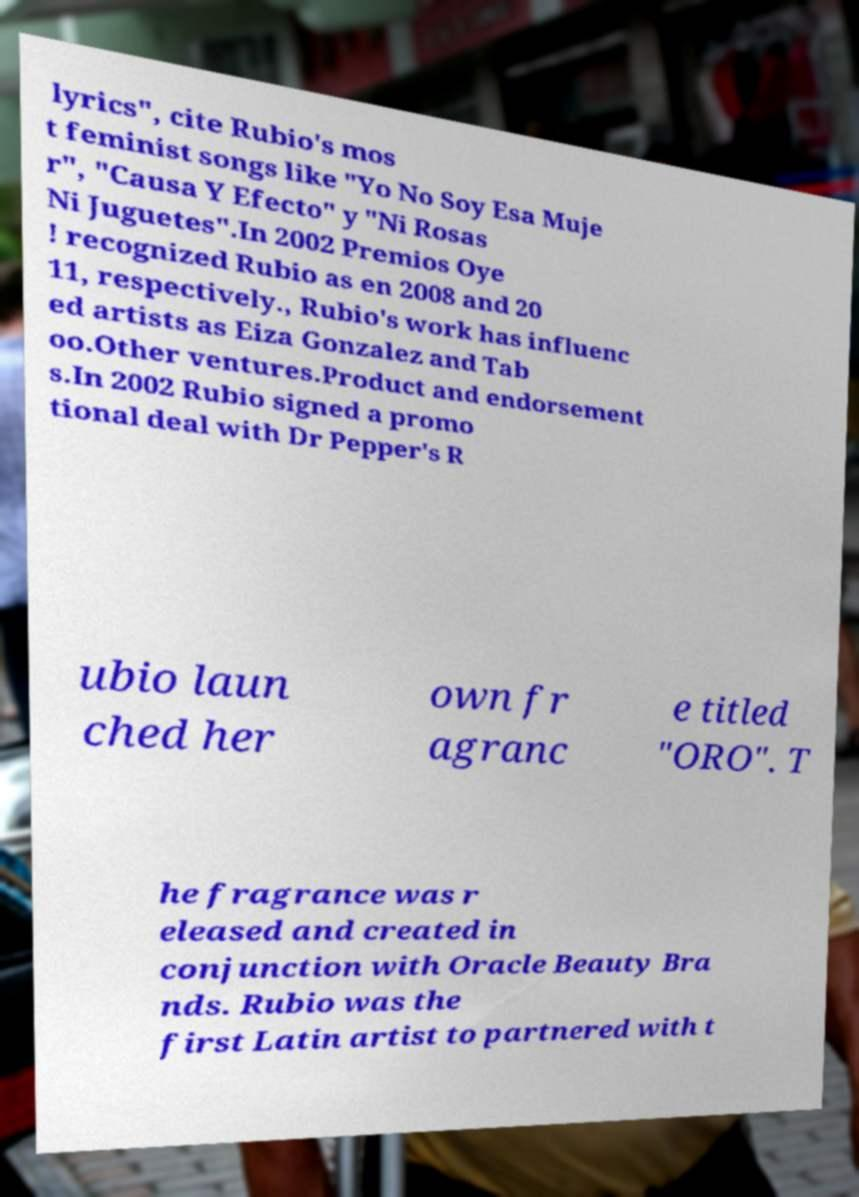For documentation purposes, I need the text within this image transcribed. Could you provide that? lyrics", cite Rubio's mos t feminist songs like "Yo No Soy Esa Muje r", "Causa Y Efecto" y "Ni Rosas Ni Juguetes".In 2002 Premios Oye ! recognized Rubio as en 2008 and 20 11, respectively., Rubio's work has influenc ed artists as Eiza Gonzalez and Tab oo.Other ventures.Product and endorsement s.In 2002 Rubio signed a promo tional deal with Dr Pepper's R ubio laun ched her own fr agranc e titled "ORO". T he fragrance was r eleased and created in conjunction with Oracle Beauty Bra nds. Rubio was the first Latin artist to partnered with t 